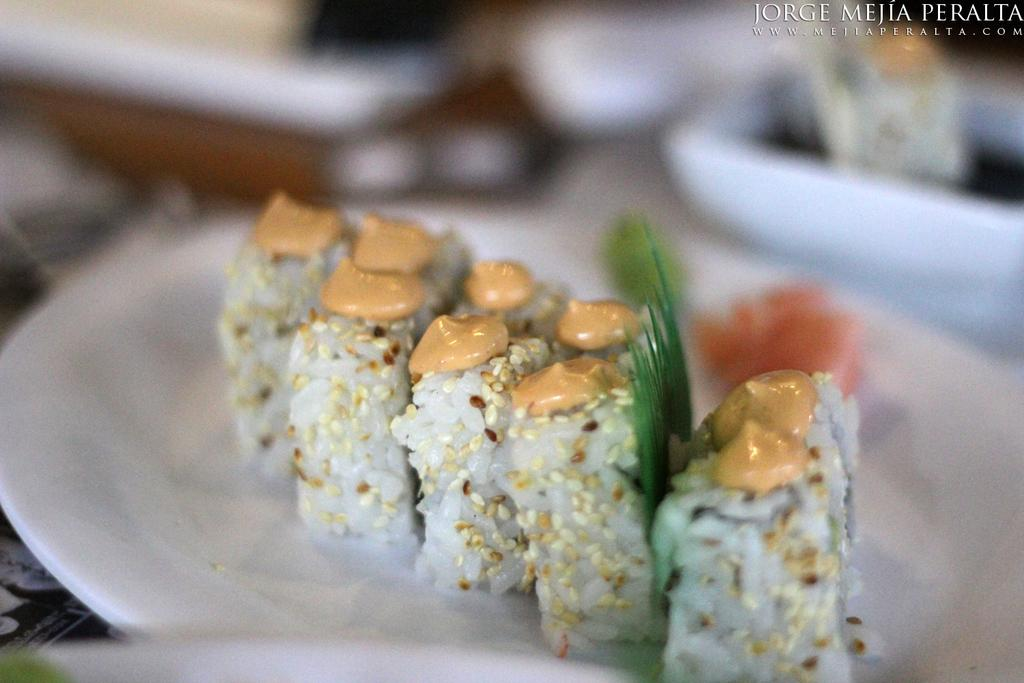What is on the plate that is visible in the image? There is food on a plate in the image. Where is the plate located in the image? The plate is on a table in the image. What else can be seen on the table in the image? There are objects on the table in the image. What type of metal is the son using to cut the bread in the image? There is no son or bread present in the image, and therefore no such activity can be observed. 